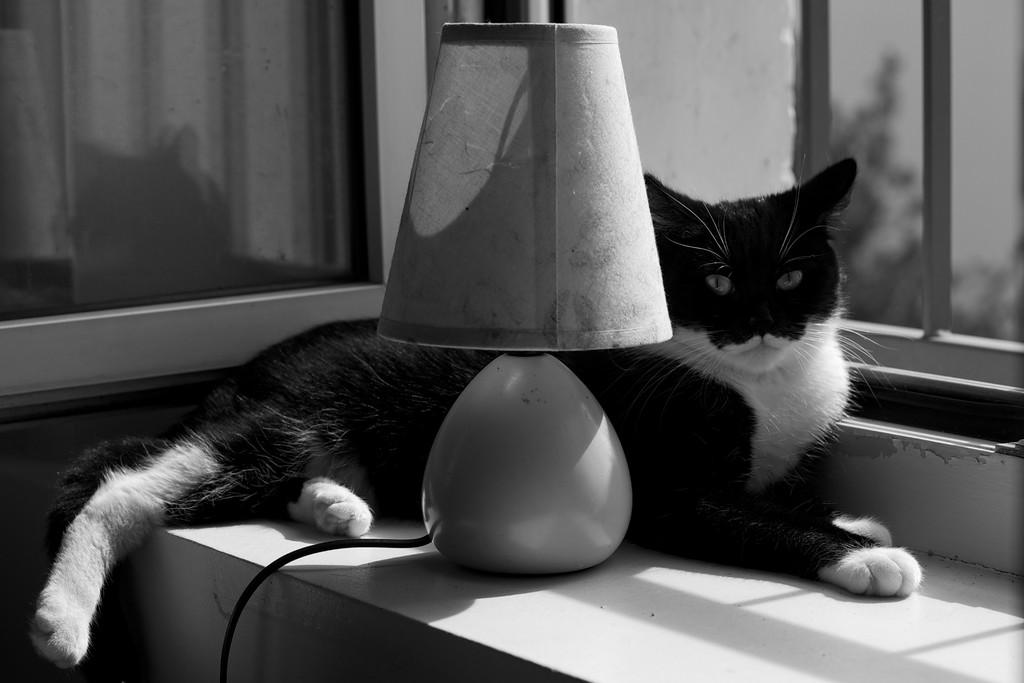What type of animal can be seen in the image? There is a cat in the image. What object is providing light in the image? There is a lamp in the image. What can be seen in the background of the image? There is a glass window in the background of the image. What is visible through the glass window? A tree is visible through the glass window. What songs is the cat singing in the image? Cats do not sing songs, so there are no songs being sung by the cat in the image. What type of property is the cat sitting on in the image? The provided facts do not mention any property, so we cannot determine the type of property the cat is sitting on in the image. 